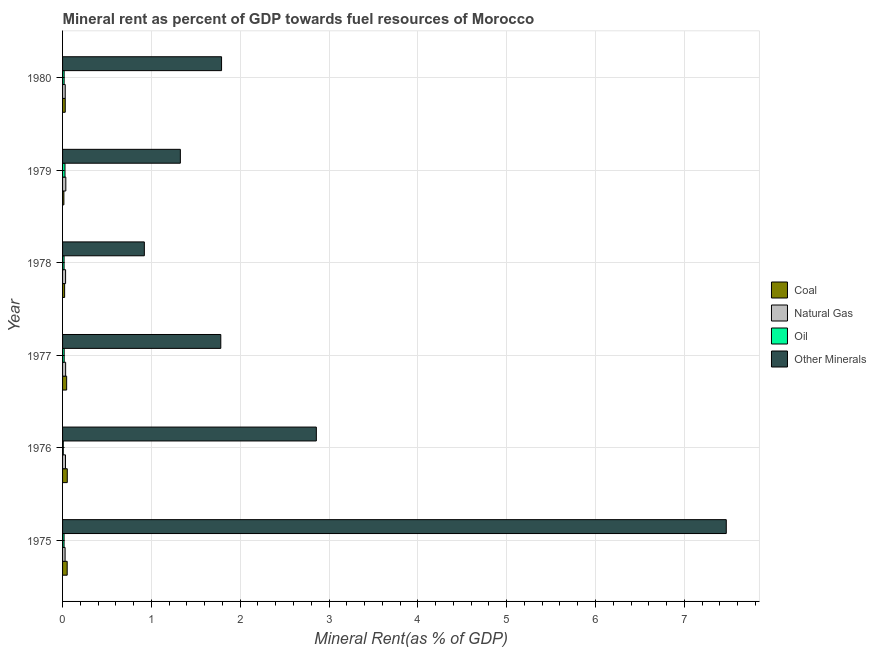Are the number of bars per tick equal to the number of legend labels?
Your response must be concise. Yes. Are the number of bars on each tick of the Y-axis equal?
Offer a terse response. Yes. How many bars are there on the 5th tick from the top?
Give a very brief answer. 4. What is the natural gas rent in 1978?
Give a very brief answer. 0.03. Across all years, what is the maximum  rent of other minerals?
Offer a terse response. 7.47. Across all years, what is the minimum oil rent?
Offer a terse response. 0.01. In which year was the natural gas rent maximum?
Provide a short and direct response. 1979. In which year was the coal rent minimum?
Keep it short and to the point. 1979. What is the total oil rent in the graph?
Make the answer very short. 0.11. What is the difference between the natural gas rent in 1980 and the  rent of other minerals in 1979?
Offer a very short reply. -1.3. What is the average coal rent per year?
Provide a short and direct response. 0.04. In the year 1979, what is the difference between the  rent of other minerals and coal rent?
Offer a very short reply. 1.31. In how many years, is the oil rent greater than 3.8 %?
Your response must be concise. 0. What is the ratio of the oil rent in 1975 to that in 1976?
Your response must be concise. 2.12. What is the difference between the highest and the second highest natural gas rent?
Provide a succinct answer. 0. What is the difference between the highest and the lowest  rent of other minerals?
Offer a very short reply. 6.55. In how many years, is the natural gas rent greater than the average natural gas rent taken over all years?
Offer a terse response. 4. Is it the case that in every year, the sum of the coal rent and oil rent is greater than the sum of  rent of other minerals and natural gas rent?
Provide a succinct answer. No. What does the 4th bar from the top in 1975 represents?
Keep it short and to the point. Coal. What does the 2nd bar from the bottom in 1979 represents?
Make the answer very short. Natural Gas. Is it the case that in every year, the sum of the coal rent and natural gas rent is greater than the oil rent?
Your answer should be compact. Yes. Are all the bars in the graph horizontal?
Your response must be concise. Yes. How many years are there in the graph?
Your answer should be very brief. 6. What is the difference between two consecutive major ticks on the X-axis?
Offer a very short reply. 1. Are the values on the major ticks of X-axis written in scientific E-notation?
Your answer should be compact. No. Does the graph contain any zero values?
Your answer should be very brief. No. What is the title of the graph?
Your answer should be very brief. Mineral rent as percent of GDP towards fuel resources of Morocco. What is the label or title of the X-axis?
Offer a very short reply. Mineral Rent(as % of GDP). What is the label or title of the Y-axis?
Provide a short and direct response. Year. What is the Mineral Rent(as % of GDP) of Coal in 1975?
Your response must be concise. 0.05. What is the Mineral Rent(as % of GDP) of Natural Gas in 1975?
Offer a terse response. 0.03. What is the Mineral Rent(as % of GDP) of Oil in 1975?
Your answer should be compact. 0.02. What is the Mineral Rent(as % of GDP) in Other Minerals in 1975?
Provide a succinct answer. 7.47. What is the Mineral Rent(as % of GDP) of Coal in 1976?
Offer a very short reply. 0.05. What is the Mineral Rent(as % of GDP) of Natural Gas in 1976?
Keep it short and to the point. 0.03. What is the Mineral Rent(as % of GDP) in Oil in 1976?
Offer a very short reply. 0.01. What is the Mineral Rent(as % of GDP) in Other Minerals in 1976?
Your answer should be very brief. 2.86. What is the Mineral Rent(as % of GDP) of Coal in 1977?
Make the answer very short. 0.05. What is the Mineral Rent(as % of GDP) in Natural Gas in 1977?
Your response must be concise. 0.03. What is the Mineral Rent(as % of GDP) of Oil in 1977?
Provide a short and direct response. 0.02. What is the Mineral Rent(as % of GDP) of Other Minerals in 1977?
Provide a succinct answer. 1.78. What is the Mineral Rent(as % of GDP) in Coal in 1978?
Give a very brief answer. 0.02. What is the Mineral Rent(as % of GDP) in Natural Gas in 1978?
Make the answer very short. 0.03. What is the Mineral Rent(as % of GDP) of Oil in 1978?
Your answer should be compact. 0.02. What is the Mineral Rent(as % of GDP) of Other Minerals in 1978?
Make the answer very short. 0.92. What is the Mineral Rent(as % of GDP) of Coal in 1979?
Your response must be concise. 0.01. What is the Mineral Rent(as % of GDP) of Natural Gas in 1979?
Your answer should be compact. 0.04. What is the Mineral Rent(as % of GDP) in Oil in 1979?
Offer a very short reply. 0.03. What is the Mineral Rent(as % of GDP) of Other Minerals in 1979?
Offer a terse response. 1.33. What is the Mineral Rent(as % of GDP) in Coal in 1980?
Your response must be concise. 0.03. What is the Mineral Rent(as % of GDP) of Natural Gas in 1980?
Give a very brief answer. 0.03. What is the Mineral Rent(as % of GDP) in Oil in 1980?
Your answer should be compact. 0.02. What is the Mineral Rent(as % of GDP) in Other Minerals in 1980?
Provide a short and direct response. 1.79. Across all years, what is the maximum Mineral Rent(as % of GDP) of Coal?
Offer a terse response. 0.05. Across all years, what is the maximum Mineral Rent(as % of GDP) of Natural Gas?
Your answer should be compact. 0.04. Across all years, what is the maximum Mineral Rent(as % of GDP) of Oil?
Keep it short and to the point. 0.03. Across all years, what is the maximum Mineral Rent(as % of GDP) in Other Minerals?
Provide a short and direct response. 7.47. Across all years, what is the minimum Mineral Rent(as % of GDP) in Coal?
Give a very brief answer. 0.01. Across all years, what is the minimum Mineral Rent(as % of GDP) in Natural Gas?
Offer a very short reply. 0.03. Across all years, what is the minimum Mineral Rent(as % of GDP) in Oil?
Offer a very short reply. 0.01. Across all years, what is the minimum Mineral Rent(as % of GDP) in Other Minerals?
Offer a terse response. 0.92. What is the total Mineral Rent(as % of GDP) in Coal in the graph?
Your answer should be compact. 0.22. What is the total Mineral Rent(as % of GDP) in Natural Gas in the graph?
Make the answer very short. 0.2. What is the total Mineral Rent(as % of GDP) of Oil in the graph?
Offer a terse response. 0.11. What is the total Mineral Rent(as % of GDP) of Other Minerals in the graph?
Make the answer very short. 16.15. What is the difference between the Mineral Rent(as % of GDP) of Coal in 1975 and that in 1976?
Make the answer very short. -0. What is the difference between the Mineral Rent(as % of GDP) of Natural Gas in 1975 and that in 1976?
Ensure brevity in your answer.  -0. What is the difference between the Mineral Rent(as % of GDP) of Oil in 1975 and that in 1976?
Your answer should be very brief. 0.01. What is the difference between the Mineral Rent(as % of GDP) of Other Minerals in 1975 and that in 1976?
Your answer should be very brief. 4.62. What is the difference between the Mineral Rent(as % of GDP) of Coal in 1975 and that in 1977?
Your answer should be very brief. 0.01. What is the difference between the Mineral Rent(as % of GDP) of Natural Gas in 1975 and that in 1977?
Give a very brief answer. -0.01. What is the difference between the Mineral Rent(as % of GDP) in Oil in 1975 and that in 1977?
Ensure brevity in your answer.  -0. What is the difference between the Mineral Rent(as % of GDP) in Other Minerals in 1975 and that in 1977?
Your answer should be compact. 5.69. What is the difference between the Mineral Rent(as % of GDP) of Coal in 1975 and that in 1978?
Ensure brevity in your answer.  0.03. What is the difference between the Mineral Rent(as % of GDP) in Natural Gas in 1975 and that in 1978?
Offer a terse response. -0.01. What is the difference between the Mineral Rent(as % of GDP) in Oil in 1975 and that in 1978?
Your response must be concise. -0. What is the difference between the Mineral Rent(as % of GDP) of Other Minerals in 1975 and that in 1978?
Provide a succinct answer. 6.55. What is the difference between the Mineral Rent(as % of GDP) in Coal in 1975 and that in 1979?
Keep it short and to the point. 0.04. What is the difference between the Mineral Rent(as % of GDP) in Natural Gas in 1975 and that in 1979?
Provide a short and direct response. -0.01. What is the difference between the Mineral Rent(as % of GDP) of Oil in 1975 and that in 1979?
Make the answer very short. -0.01. What is the difference between the Mineral Rent(as % of GDP) of Other Minerals in 1975 and that in 1979?
Your response must be concise. 6.15. What is the difference between the Mineral Rent(as % of GDP) of Coal in 1975 and that in 1980?
Make the answer very short. 0.02. What is the difference between the Mineral Rent(as % of GDP) of Natural Gas in 1975 and that in 1980?
Your answer should be compact. -0. What is the difference between the Mineral Rent(as % of GDP) in Oil in 1975 and that in 1980?
Make the answer very short. -0. What is the difference between the Mineral Rent(as % of GDP) of Other Minerals in 1975 and that in 1980?
Offer a terse response. 5.68. What is the difference between the Mineral Rent(as % of GDP) of Coal in 1976 and that in 1977?
Make the answer very short. 0.01. What is the difference between the Mineral Rent(as % of GDP) in Natural Gas in 1976 and that in 1977?
Ensure brevity in your answer.  -0. What is the difference between the Mineral Rent(as % of GDP) of Oil in 1976 and that in 1977?
Offer a terse response. -0.01. What is the difference between the Mineral Rent(as % of GDP) of Other Minerals in 1976 and that in 1977?
Ensure brevity in your answer.  1.08. What is the difference between the Mineral Rent(as % of GDP) of Coal in 1976 and that in 1978?
Keep it short and to the point. 0.03. What is the difference between the Mineral Rent(as % of GDP) of Natural Gas in 1976 and that in 1978?
Your answer should be very brief. -0. What is the difference between the Mineral Rent(as % of GDP) of Oil in 1976 and that in 1978?
Your response must be concise. -0.01. What is the difference between the Mineral Rent(as % of GDP) of Other Minerals in 1976 and that in 1978?
Give a very brief answer. 1.94. What is the difference between the Mineral Rent(as % of GDP) in Coal in 1976 and that in 1979?
Your answer should be very brief. 0.04. What is the difference between the Mineral Rent(as % of GDP) of Natural Gas in 1976 and that in 1979?
Your answer should be compact. -0. What is the difference between the Mineral Rent(as % of GDP) of Oil in 1976 and that in 1979?
Offer a very short reply. -0.02. What is the difference between the Mineral Rent(as % of GDP) of Other Minerals in 1976 and that in 1979?
Offer a terse response. 1.53. What is the difference between the Mineral Rent(as % of GDP) of Coal in 1976 and that in 1980?
Provide a succinct answer. 0.02. What is the difference between the Mineral Rent(as % of GDP) in Natural Gas in 1976 and that in 1980?
Keep it short and to the point. 0. What is the difference between the Mineral Rent(as % of GDP) of Oil in 1976 and that in 1980?
Keep it short and to the point. -0.01. What is the difference between the Mineral Rent(as % of GDP) of Other Minerals in 1976 and that in 1980?
Your answer should be compact. 1.07. What is the difference between the Mineral Rent(as % of GDP) of Coal in 1977 and that in 1978?
Ensure brevity in your answer.  0.02. What is the difference between the Mineral Rent(as % of GDP) in Oil in 1977 and that in 1978?
Give a very brief answer. 0. What is the difference between the Mineral Rent(as % of GDP) in Other Minerals in 1977 and that in 1978?
Ensure brevity in your answer.  0.86. What is the difference between the Mineral Rent(as % of GDP) of Coal in 1977 and that in 1979?
Your answer should be very brief. 0.03. What is the difference between the Mineral Rent(as % of GDP) of Natural Gas in 1977 and that in 1979?
Your answer should be compact. -0. What is the difference between the Mineral Rent(as % of GDP) in Oil in 1977 and that in 1979?
Ensure brevity in your answer.  -0.01. What is the difference between the Mineral Rent(as % of GDP) in Other Minerals in 1977 and that in 1979?
Keep it short and to the point. 0.46. What is the difference between the Mineral Rent(as % of GDP) in Coal in 1977 and that in 1980?
Keep it short and to the point. 0.02. What is the difference between the Mineral Rent(as % of GDP) of Natural Gas in 1977 and that in 1980?
Offer a terse response. 0. What is the difference between the Mineral Rent(as % of GDP) in Oil in 1977 and that in 1980?
Your answer should be compact. 0. What is the difference between the Mineral Rent(as % of GDP) of Other Minerals in 1977 and that in 1980?
Provide a short and direct response. -0.01. What is the difference between the Mineral Rent(as % of GDP) in Coal in 1978 and that in 1979?
Make the answer very short. 0.01. What is the difference between the Mineral Rent(as % of GDP) of Natural Gas in 1978 and that in 1979?
Ensure brevity in your answer.  -0. What is the difference between the Mineral Rent(as % of GDP) in Oil in 1978 and that in 1979?
Provide a short and direct response. -0.01. What is the difference between the Mineral Rent(as % of GDP) of Other Minerals in 1978 and that in 1979?
Offer a very short reply. -0.41. What is the difference between the Mineral Rent(as % of GDP) in Coal in 1978 and that in 1980?
Provide a succinct answer. -0.01. What is the difference between the Mineral Rent(as % of GDP) in Natural Gas in 1978 and that in 1980?
Your response must be concise. 0. What is the difference between the Mineral Rent(as % of GDP) in Oil in 1978 and that in 1980?
Provide a short and direct response. -0. What is the difference between the Mineral Rent(as % of GDP) of Other Minerals in 1978 and that in 1980?
Ensure brevity in your answer.  -0.87. What is the difference between the Mineral Rent(as % of GDP) in Coal in 1979 and that in 1980?
Give a very brief answer. -0.02. What is the difference between the Mineral Rent(as % of GDP) of Natural Gas in 1979 and that in 1980?
Offer a very short reply. 0.01. What is the difference between the Mineral Rent(as % of GDP) in Oil in 1979 and that in 1980?
Provide a succinct answer. 0.01. What is the difference between the Mineral Rent(as % of GDP) of Other Minerals in 1979 and that in 1980?
Offer a very short reply. -0.46. What is the difference between the Mineral Rent(as % of GDP) of Coal in 1975 and the Mineral Rent(as % of GDP) of Natural Gas in 1976?
Your response must be concise. 0.02. What is the difference between the Mineral Rent(as % of GDP) of Coal in 1975 and the Mineral Rent(as % of GDP) of Oil in 1976?
Provide a short and direct response. 0.04. What is the difference between the Mineral Rent(as % of GDP) of Coal in 1975 and the Mineral Rent(as % of GDP) of Other Minerals in 1976?
Ensure brevity in your answer.  -2.81. What is the difference between the Mineral Rent(as % of GDP) in Natural Gas in 1975 and the Mineral Rent(as % of GDP) in Oil in 1976?
Your answer should be compact. 0.02. What is the difference between the Mineral Rent(as % of GDP) in Natural Gas in 1975 and the Mineral Rent(as % of GDP) in Other Minerals in 1976?
Make the answer very short. -2.83. What is the difference between the Mineral Rent(as % of GDP) of Oil in 1975 and the Mineral Rent(as % of GDP) of Other Minerals in 1976?
Give a very brief answer. -2.84. What is the difference between the Mineral Rent(as % of GDP) in Coal in 1975 and the Mineral Rent(as % of GDP) in Natural Gas in 1977?
Your response must be concise. 0.02. What is the difference between the Mineral Rent(as % of GDP) of Coal in 1975 and the Mineral Rent(as % of GDP) of Oil in 1977?
Offer a terse response. 0.03. What is the difference between the Mineral Rent(as % of GDP) in Coal in 1975 and the Mineral Rent(as % of GDP) in Other Minerals in 1977?
Provide a succinct answer. -1.73. What is the difference between the Mineral Rent(as % of GDP) in Natural Gas in 1975 and the Mineral Rent(as % of GDP) in Oil in 1977?
Ensure brevity in your answer.  0.01. What is the difference between the Mineral Rent(as % of GDP) in Natural Gas in 1975 and the Mineral Rent(as % of GDP) in Other Minerals in 1977?
Your answer should be compact. -1.75. What is the difference between the Mineral Rent(as % of GDP) in Oil in 1975 and the Mineral Rent(as % of GDP) in Other Minerals in 1977?
Ensure brevity in your answer.  -1.76. What is the difference between the Mineral Rent(as % of GDP) in Coal in 1975 and the Mineral Rent(as % of GDP) in Natural Gas in 1978?
Offer a very short reply. 0.02. What is the difference between the Mineral Rent(as % of GDP) of Coal in 1975 and the Mineral Rent(as % of GDP) of Oil in 1978?
Give a very brief answer. 0.04. What is the difference between the Mineral Rent(as % of GDP) in Coal in 1975 and the Mineral Rent(as % of GDP) in Other Minerals in 1978?
Offer a very short reply. -0.87. What is the difference between the Mineral Rent(as % of GDP) in Natural Gas in 1975 and the Mineral Rent(as % of GDP) in Oil in 1978?
Provide a succinct answer. 0.01. What is the difference between the Mineral Rent(as % of GDP) in Natural Gas in 1975 and the Mineral Rent(as % of GDP) in Other Minerals in 1978?
Give a very brief answer. -0.89. What is the difference between the Mineral Rent(as % of GDP) in Oil in 1975 and the Mineral Rent(as % of GDP) in Other Minerals in 1978?
Give a very brief answer. -0.9. What is the difference between the Mineral Rent(as % of GDP) in Coal in 1975 and the Mineral Rent(as % of GDP) in Natural Gas in 1979?
Keep it short and to the point. 0.02. What is the difference between the Mineral Rent(as % of GDP) in Coal in 1975 and the Mineral Rent(as % of GDP) in Oil in 1979?
Your answer should be very brief. 0.02. What is the difference between the Mineral Rent(as % of GDP) in Coal in 1975 and the Mineral Rent(as % of GDP) in Other Minerals in 1979?
Ensure brevity in your answer.  -1.27. What is the difference between the Mineral Rent(as % of GDP) of Natural Gas in 1975 and the Mineral Rent(as % of GDP) of Oil in 1979?
Your answer should be very brief. 0. What is the difference between the Mineral Rent(as % of GDP) of Natural Gas in 1975 and the Mineral Rent(as % of GDP) of Other Minerals in 1979?
Ensure brevity in your answer.  -1.3. What is the difference between the Mineral Rent(as % of GDP) of Oil in 1975 and the Mineral Rent(as % of GDP) of Other Minerals in 1979?
Offer a very short reply. -1.31. What is the difference between the Mineral Rent(as % of GDP) of Coal in 1975 and the Mineral Rent(as % of GDP) of Natural Gas in 1980?
Provide a succinct answer. 0.02. What is the difference between the Mineral Rent(as % of GDP) of Coal in 1975 and the Mineral Rent(as % of GDP) of Oil in 1980?
Offer a terse response. 0.03. What is the difference between the Mineral Rent(as % of GDP) in Coal in 1975 and the Mineral Rent(as % of GDP) in Other Minerals in 1980?
Your answer should be compact. -1.74. What is the difference between the Mineral Rent(as % of GDP) of Natural Gas in 1975 and the Mineral Rent(as % of GDP) of Oil in 1980?
Your answer should be compact. 0.01. What is the difference between the Mineral Rent(as % of GDP) of Natural Gas in 1975 and the Mineral Rent(as % of GDP) of Other Minerals in 1980?
Your response must be concise. -1.76. What is the difference between the Mineral Rent(as % of GDP) of Oil in 1975 and the Mineral Rent(as % of GDP) of Other Minerals in 1980?
Your answer should be very brief. -1.77. What is the difference between the Mineral Rent(as % of GDP) in Coal in 1976 and the Mineral Rent(as % of GDP) in Natural Gas in 1977?
Provide a short and direct response. 0.02. What is the difference between the Mineral Rent(as % of GDP) of Coal in 1976 and the Mineral Rent(as % of GDP) of Oil in 1977?
Keep it short and to the point. 0.03. What is the difference between the Mineral Rent(as % of GDP) in Coal in 1976 and the Mineral Rent(as % of GDP) in Other Minerals in 1977?
Keep it short and to the point. -1.73. What is the difference between the Mineral Rent(as % of GDP) of Natural Gas in 1976 and the Mineral Rent(as % of GDP) of Oil in 1977?
Your answer should be very brief. 0.01. What is the difference between the Mineral Rent(as % of GDP) in Natural Gas in 1976 and the Mineral Rent(as % of GDP) in Other Minerals in 1977?
Make the answer very short. -1.75. What is the difference between the Mineral Rent(as % of GDP) in Oil in 1976 and the Mineral Rent(as % of GDP) in Other Minerals in 1977?
Provide a short and direct response. -1.77. What is the difference between the Mineral Rent(as % of GDP) of Coal in 1976 and the Mineral Rent(as % of GDP) of Natural Gas in 1978?
Your answer should be compact. 0.02. What is the difference between the Mineral Rent(as % of GDP) of Coal in 1976 and the Mineral Rent(as % of GDP) of Oil in 1978?
Your answer should be compact. 0.04. What is the difference between the Mineral Rent(as % of GDP) in Coal in 1976 and the Mineral Rent(as % of GDP) in Other Minerals in 1978?
Your answer should be very brief. -0.87. What is the difference between the Mineral Rent(as % of GDP) in Natural Gas in 1976 and the Mineral Rent(as % of GDP) in Oil in 1978?
Your answer should be very brief. 0.02. What is the difference between the Mineral Rent(as % of GDP) in Natural Gas in 1976 and the Mineral Rent(as % of GDP) in Other Minerals in 1978?
Offer a terse response. -0.89. What is the difference between the Mineral Rent(as % of GDP) in Oil in 1976 and the Mineral Rent(as % of GDP) in Other Minerals in 1978?
Your response must be concise. -0.91. What is the difference between the Mineral Rent(as % of GDP) of Coal in 1976 and the Mineral Rent(as % of GDP) of Natural Gas in 1979?
Offer a terse response. 0.02. What is the difference between the Mineral Rent(as % of GDP) of Coal in 1976 and the Mineral Rent(as % of GDP) of Oil in 1979?
Offer a terse response. 0.03. What is the difference between the Mineral Rent(as % of GDP) in Coal in 1976 and the Mineral Rent(as % of GDP) in Other Minerals in 1979?
Provide a succinct answer. -1.27. What is the difference between the Mineral Rent(as % of GDP) of Natural Gas in 1976 and the Mineral Rent(as % of GDP) of Oil in 1979?
Provide a short and direct response. 0.01. What is the difference between the Mineral Rent(as % of GDP) in Natural Gas in 1976 and the Mineral Rent(as % of GDP) in Other Minerals in 1979?
Ensure brevity in your answer.  -1.29. What is the difference between the Mineral Rent(as % of GDP) of Oil in 1976 and the Mineral Rent(as % of GDP) of Other Minerals in 1979?
Offer a very short reply. -1.32. What is the difference between the Mineral Rent(as % of GDP) of Coal in 1976 and the Mineral Rent(as % of GDP) of Natural Gas in 1980?
Make the answer very short. 0.02. What is the difference between the Mineral Rent(as % of GDP) in Coal in 1976 and the Mineral Rent(as % of GDP) in Oil in 1980?
Keep it short and to the point. 0.04. What is the difference between the Mineral Rent(as % of GDP) of Coal in 1976 and the Mineral Rent(as % of GDP) of Other Minerals in 1980?
Offer a very short reply. -1.74. What is the difference between the Mineral Rent(as % of GDP) in Natural Gas in 1976 and the Mineral Rent(as % of GDP) in Oil in 1980?
Ensure brevity in your answer.  0.01. What is the difference between the Mineral Rent(as % of GDP) of Natural Gas in 1976 and the Mineral Rent(as % of GDP) of Other Minerals in 1980?
Provide a short and direct response. -1.76. What is the difference between the Mineral Rent(as % of GDP) in Oil in 1976 and the Mineral Rent(as % of GDP) in Other Minerals in 1980?
Provide a short and direct response. -1.78. What is the difference between the Mineral Rent(as % of GDP) of Coal in 1977 and the Mineral Rent(as % of GDP) of Natural Gas in 1978?
Offer a very short reply. 0.01. What is the difference between the Mineral Rent(as % of GDP) in Coal in 1977 and the Mineral Rent(as % of GDP) in Oil in 1978?
Offer a terse response. 0.03. What is the difference between the Mineral Rent(as % of GDP) in Coal in 1977 and the Mineral Rent(as % of GDP) in Other Minerals in 1978?
Offer a terse response. -0.87. What is the difference between the Mineral Rent(as % of GDP) in Natural Gas in 1977 and the Mineral Rent(as % of GDP) in Oil in 1978?
Your response must be concise. 0.02. What is the difference between the Mineral Rent(as % of GDP) of Natural Gas in 1977 and the Mineral Rent(as % of GDP) of Other Minerals in 1978?
Make the answer very short. -0.89. What is the difference between the Mineral Rent(as % of GDP) in Oil in 1977 and the Mineral Rent(as % of GDP) in Other Minerals in 1978?
Your answer should be compact. -0.9. What is the difference between the Mineral Rent(as % of GDP) in Coal in 1977 and the Mineral Rent(as % of GDP) in Natural Gas in 1979?
Provide a succinct answer. 0.01. What is the difference between the Mineral Rent(as % of GDP) in Coal in 1977 and the Mineral Rent(as % of GDP) in Oil in 1979?
Your response must be concise. 0.02. What is the difference between the Mineral Rent(as % of GDP) in Coal in 1977 and the Mineral Rent(as % of GDP) in Other Minerals in 1979?
Ensure brevity in your answer.  -1.28. What is the difference between the Mineral Rent(as % of GDP) of Natural Gas in 1977 and the Mineral Rent(as % of GDP) of Oil in 1979?
Your answer should be very brief. 0.01. What is the difference between the Mineral Rent(as % of GDP) in Natural Gas in 1977 and the Mineral Rent(as % of GDP) in Other Minerals in 1979?
Offer a terse response. -1.29. What is the difference between the Mineral Rent(as % of GDP) in Oil in 1977 and the Mineral Rent(as % of GDP) in Other Minerals in 1979?
Offer a very short reply. -1.31. What is the difference between the Mineral Rent(as % of GDP) of Coal in 1977 and the Mineral Rent(as % of GDP) of Natural Gas in 1980?
Offer a terse response. 0.02. What is the difference between the Mineral Rent(as % of GDP) in Coal in 1977 and the Mineral Rent(as % of GDP) in Oil in 1980?
Offer a terse response. 0.03. What is the difference between the Mineral Rent(as % of GDP) of Coal in 1977 and the Mineral Rent(as % of GDP) of Other Minerals in 1980?
Provide a succinct answer. -1.74. What is the difference between the Mineral Rent(as % of GDP) in Natural Gas in 1977 and the Mineral Rent(as % of GDP) in Oil in 1980?
Give a very brief answer. 0.02. What is the difference between the Mineral Rent(as % of GDP) of Natural Gas in 1977 and the Mineral Rent(as % of GDP) of Other Minerals in 1980?
Give a very brief answer. -1.76. What is the difference between the Mineral Rent(as % of GDP) of Oil in 1977 and the Mineral Rent(as % of GDP) of Other Minerals in 1980?
Your answer should be very brief. -1.77. What is the difference between the Mineral Rent(as % of GDP) in Coal in 1978 and the Mineral Rent(as % of GDP) in Natural Gas in 1979?
Provide a succinct answer. -0.01. What is the difference between the Mineral Rent(as % of GDP) in Coal in 1978 and the Mineral Rent(as % of GDP) in Oil in 1979?
Your answer should be compact. -0. What is the difference between the Mineral Rent(as % of GDP) in Coal in 1978 and the Mineral Rent(as % of GDP) in Other Minerals in 1979?
Provide a short and direct response. -1.3. What is the difference between the Mineral Rent(as % of GDP) in Natural Gas in 1978 and the Mineral Rent(as % of GDP) in Oil in 1979?
Provide a succinct answer. 0.01. What is the difference between the Mineral Rent(as % of GDP) in Natural Gas in 1978 and the Mineral Rent(as % of GDP) in Other Minerals in 1979?
Provide a succinct answer. -1.29. What is the difference between the Mineral Rent(as % of GDP) in Oil in 1978 and the Mineral Rent(as % of GDP) in Other Minerals in 1979?
Ensure brevity in your answer.  -1.31. What is the difference between the Mineral Rent(as % of GDP) of Coal in 1978 and the Mineral Rent(as % of GDP) of Natural Gas in 1980?
Offer a very short reply. -0.01. What is the difference between the Mineral Rent(as % of GDP) in Coal in 1978 and the Mineral Rent(as % of GDP) in Oil in 1980?
Give a very brief answer. 0.01. What is the difference between the Mineral Rent(as % of GDP) of Coal in 1978 and the Mineral Rent(as % of GDP) of Other Minerals in 1980?
Make the answer very short. -1.77. What is the difference between the Mineral Rent(as % of GDP) in Natural Gas in 1978 and the Mineral Rent(as % of GDP) in Oil in 1980?
Provide a short and direct response. 0.02. What is the difference between the Mineral Rent(as % of GDP) of Natural Gas in 1978 and the Mineral Rent(as % of GDP) of Other Minerals in 1980?
Keep it short and to the point. -1.76. What is the difference between the Mineral Rent(as % of GDP) in Oil in 1978 and the Mineral Rent(as % of GDP) in Other Minerals in 1980?
Your answer should be very brief. -1.77. What is the difference between the Mineral Rent(as % of GDP) in Coal in 1979 and the Mineral Rent(as % of GDP) in Natural Gas in 1980?
Make the answer very short. -0.02. What is the difference between the Mineral Rent(as % of GDP) in Coal in 1979 and the Mineral Rent(as % of GDP) in Oil in 1980?
Provide a succinct answer. -0. What is the difference between the Mineral Rent(as % of GDP) in Coal in 1979 and the Mineral Rent(as % of GDP) in Other Minerals in 1980?
Provide a succinct answer. -1.78. What is the difference between the Mineral Rent(as % of GDP) of Natural Gas in 1979 and the Mineral Rent(as % of GDP) of Oil in 1980?
Keep it short and to the point. 0.02. What is the difference between the Mineral Rent(as % of GDP) of Natural Gas in 1979 and the Mineral Rent(as % of GDP) of Other Minerals in 1980?
Give a very brief answer. -1.75. What is the difference between the Mineral Rent(as % of GDP) of Oil in 1979 and the Mineral Rent(as % of GDP) of Other Minerals in 1980?
Your response must be concise. -1.76. What is the average Mineral Rent(as % of GDP) of Coal per year?
Offer a terse response. 0.04. What is the average Mineral Rent(as % of GDP) of Natural Gas per year?
Keep it short and to the point. 0.03. What is the average Mineral Rent(as % of GDP) of Oil per year?
Your response must be concise. 0.02. What is the average Mineral Rent(as % of GDP) of Other Minerals per year?
Provide a short and direct response. 2.69. In the year 1975, what is the difference between the Mineral Rent(as % of GDP) of Coal and Mineral Rent(as % of GDP) of Natural Gas?
Provide a succinct answer. 0.02. In the year 1975, what is the difference between the Mineral Rent(as % of GDP) in Coal and Mineral Rent(as % of GDP) in Oil?
Make the answer very short. 0.04. In the year 1975, what is the difference between the Mineral Rent(as % of GDP) in Coal and Mineral Rent(as % of GDP) in Other Minerals?
Make the answer very short. -7.42. In the year 1975, what is the difference between the Mineral Rent(as % of GDP) of Natural Gas and Mineral Rent(as % of GDP) of Oil?
Your answer should be very brief. 0.01. In the year 1975, what is the difference between the Mineral Rent(as % of GDP) in Natural Gas and Mineral Rent(as % of GDP) in Other Minerals?
Give a very brief answer. -7.44. In the year 1975, what is the difference between the Mineral Rent(as % of GDP) of Oil and Mineral Rent(as % of GDP) of Other Minerals?
Ensure brevity in your answer.  -7.46. In the year 1976, what is the difference between the Mineral Rent(as % of GDP) of Coal and Mineral Rent(as % of GDP) of Natural Gas?
Keep it short and to the point. 0.02. In the year 1976, what is the difference between the Mineral Rent(as % of GDP) in Coal and Mineral Rent(as % of GDP) in Oil?
Offer a terse response. 0.05. In the year 1976, what is the difference between the Mineral Rent(as % of GDP) of Coal and Mineral Rent(as % of GDP) of Other Minerals?
Provide a short and direct response. -2.8. In the year 1976, what is the difference between the Mineral Rent(as % of GDP) of Natural Gas and Mineral Rent(as % of GDP) of Oil?
Give a very brief answer. 0.02. In the year 1976, what is the difference between the Mineral Rent(as % of GDP) of Natural Gas and Mineral Rent(as % of GDP) of Other Minerals?
Offer a very short reply. -2.82. In the year 1976, what is the difference between the Mineral Rent(as % of GDP) of Oil and Mineral Rent(as % of GDP) of Other Minerals?
Give a very brief answer. -2.85. In the year 1977, what is the difference between the Mineral Rent(as % of GDP) of Coal and Mineral Rent(as % of GDP) of Natural Gas?
Offer a very short reply. 0.01. In the year 1977, what is the difference between the Mineral Rent(as % of GDP) in Coal and Mineral Rent(as % of GDP) in Oil?
Keep it short and to the point. 0.03. In the year 1977, what is the difference between the Mineral Rent(as % of GDP) in Coal and Mineral Rent(as % of GDP) in Other Minerals?
Your answer should be compact. -1.74. In the year 1977, what is the difference between the Mineral Rent(as % of GDP) in Natural Gas and Mineral Rent(as % of GDP) in Oil?
Offer a very short reply. 0.02. In the year 1977, what is the difference between the Mineral Rent(as % of GDP) of Natural Gas and Mineral Rent(as % of GDP) of Other Minerals?
Give a very brief answer. -1.75. In the year 1977, what is the difference between the Mineral Rent(as % of GDP) in Oil and Mineral Rent(as % of GDP) in Other Minerals?
Provide a short and direct response. -1.76. In the year 1978, what is the difference between the Mineral Rent(as % of GDP) in Coal and Mineral Rent(as % of GDP) in Natural Gas?
Your answer should be very brief. -0.01. In the year 1978, what is the difference between the Mineral Rent(as % of GDP) in Coal and Mineral Rent(as % of GDP) in Oil?
Ensure brevity in your answer.  0.01. In the year 1978, what is the difference between the Mineral Rent(as % of GDP) in Coal and Mineral Rent(as % of GDP) in Other Minerals?
Ensure brevity in your answer.  -0.9. In the year 1978, what is the difference between the Mineral Rent(as % of GDP) of Natural Gas and Mineral Rent(as % of GDP) of Oil?
Provide a succinct answer. 0.02. In the year 1978, what is the difference between the Mineral Rent(as % of GDP) of Natural Gas and Mineral Rent(as % of GDP) of Other Minerals?
Ensure brevity in your answer.  -0.89. In the year 1978, what is the difference between the Mineral Rent(as % of GDP) of Oil and Mineral Rent(as % of GDP) of Other Minerals?
Make the answer very short. -0.9. In the year 1979, what is the difference between the Mineral Rent(as % of GDP) of Coal and Mineral Rent(as % of GDP) of Natural Gas?
Make the answer very short. -0.02. In the year 1979, what is the difference between the Mineral Rent(as % of GDP) in Coal and Mineral Rent(as % of GDP) in Oil?
Provide a short and direct response. -0.01. In the year 1979, what is the difference between the Mineral Rent(as % of GDP) of Coal and Mineral Rent(as % of GDP) of Other Minerals?
Keep it short and to the point. -1.31. In the year 1979, what is the difference between the Mineral Rent(as % of GDP) of Natural Gas and Mineral Rent(as % of GDP) of Oil?
Provide a succinct answer. 0.01. In the year 1979, what is the difference between the Mineral Rent(as % of GDP) of Natural Gas and Mineral Rent(as % of GDP) of Other Minerals?
Ensure brevity in your answer.  -1.29. In the year 1979, what is the difference between the Mineral Rent(as % of GDP) in Oil and Mineral Rent(as % of GDP) in Other Minerals?
Your response must be concise. -1.3. In the year 1980, what is the difference between the Mineral Rent(as % of GDP) of Coal and Mineral Rent(as % of GDP) of Oil?
Give a very brief answer. 0.01. In the year 1980, what is the difference between the Mineral Rent(as % of GDP) of Coal and Mineral Rent(as % of GDP) of Other Minerals?
Provide a short and direct response. -1.76. In the year 1980, what is the difference between the Mineral Rent(as % of GDP) in Natural Gas and Mineral Rent(as % of GDP) in Oil?
Provide a short and direct response. 0.01. In the year 1980, what is the difference between the Mineral Rent(as % of GDP) in Natural Gas and Mineral Rent(as % of GDP) in Other Minerals?
Provide a short and direct response. -1.76. In the year 1980, what is the difference between the Mineral Rent(as % of GDP) in Oil and Mineral Rent(as % of GDP) in Other Minerals?
Your response must be concise. -1.77. What is the ratio of the Mineral Rent(as % of GDP) in Coal in 1975 to that in 1976?
Give a very brief answer. 0.98. What is the ratio of the Mineral Rent(as % of GDP) of Natural Gas in 1975 to that in 1976?
Make the answer very short. 0.87. What is the ratio of the Mineral Rent(as % of GDP) of Oil in 1975 to that in 1976?
Your answer should be compact. 2.12. What is the ratio of the Mineral Rent(as % of GDP) of Other Minerals in 1975 to that in 1976?
Provide a succinct answer. 2.62. What is the ratio of the Mineral Rent(as % of GDP) of Coal in 1975 to that in 1977?
Offer a very short reply. 1.13. What is the ratio of the Mineral Rent(as % of GDP) of Natural Gas in 1975 to that in 1977?
Your answer should be compact. 0.82. What is the ratio of the Mineral Rent(as % of GDP) in Oil in 1975 to that in 1977?
Your answer should be very brief. 0.93. What is the ratio of the Mineral Rent(as % of GDP) in Other Minerals in 1975 to that in 1977?
Offer a terse response. 4.19. What is the ratio of the Mineral Rent(as % of GDP) in Coal in 1975 to that in 1978?
Provide a succinct answer. 2.25. What is the ratio of the Mineral Rent(as % of GDP) in Natural Gas in 1975 to that in 1978?
Offer a terse response. 0.83. What is the ratio of the Mineral Rent(as % of GDP) in Oil in 1975 to that in 1978?
Offer a terse response. 0.99. What is the ratio of the Mineral Rent(as % of GDP) in Other Minerals in 1975 to that in 1978?
Your answer should be very brief. 8.12. What is the ratio of the Mineral Rent(as % of GDP) in Coal in 1975 to that in 1979?
Offer a very short reply. 3.49. What is the ratio of the Mineral Rent(as % of GDP) in Natural Gas in 1975 to that in 1979?
Keep it short and to the point. 0.77. What is the ratio of the Mineral Rent(as % of GDP) in Oil in 1975 to that in 1979?
Provide a succinct answer. 0.62. What is the ratio of the Mineral Rent(as % of GDP) of Other Minerals in 1975 to that in 1979?
Your response must be concise. 5.63. What is the ratio of the Mineral Rent(as % of GDP) of Coal in 1975 to that in 1980?
Your response must be concise. 1.72. What is the ratio of the Mineral Rent(as % of GDP) of Natural Gas in 1975 to that in 1980?
Your answer should be compact. 0.95. What is the ratio of the Mineral Rent(as % of GDP) of Oil in 1975 to that in 1980?
Offer a terse response. 0.95. What is the ratio of the Mineral Rent(as % of GDP) in Other Minerals in 1975 to that in 1980?
Your answer should be very brief. 4.17. What is the ratio of the Mineral Rent(as % of GDP) of Coal in 1976 to that in 1977?
Provide a succinct answer. 1.15. What is the ratio of the Mineral Rent(as % of GDP) in Natural Gas in 1976 to that in 1977?
Provide a short and direct response. 0.95. What is the ratio of the Mineral Rent(as % of GDP) in Oil in 1976 to that in 1977?
Provide a succinct answer. 0.44. What is the ratio of the Mineral Rent(as % of GDP) in Other Minerals in 1976 to that in 1977?
Keep it short and to the point. 1.6. What is the ratio of the Mineral Rent(as % of GDP) in Coal in 1976 to that in 1978?
Give a very brief answer. 2.29. What is the ratio of the Mineral Rent(as % of GDP) in Natural Gas in 1976 to that in 1978?
Ensure brevity in your answer.  0.96. What is the ratio of the Mineral Rent(as % of GDP) in Oil in 1976 to that in 1978?
Make the answer very short. 0.47. What is the ratio of the Mineral Rent(as % of GDP) of Other Minerals in 1976 to that in 1978?
Your response must be concise. 3.1. What is the ratio of the Mineral Rent(as % of GDP) of Coal in 1976 to that in 1979?
Offer a terse response. 3.56. What is the ratio of the Mineral Rent(as % of GDP) in Natural Gas in 1976 to that in 1979?
Your answer should be very brief. 0.89. What is the ratio of the Mineral Rent(as % of GDP) of Oil in 1976 to that in 1979?
Provide a succinct answer. 0.29. What is the ratio of the Mineral Rent(as % of GDP) in Other Minerals in 1976 to that in 1979?
Provide a succinct answer. 2.15. What is the ratio of the Mineral Rent(as % of GDP) of Coal in 1976 to that in 1980?
Your answer should be compact. 1.76. What is the ratio of the Mineral Rent(as % of GDP) of Natural Gas in 1976 to that in 1980?
Offer a very short reply. 1.09. What is the ratio of the Mineral Rent(as % of GDP) in Oil in 1976 to that in 1980?
Your answer should be very brief. 0.45. What is the ratio of the Mineral Rent(as % of GDP) in Other Minerals in 1976 to that in 1980?
Your answer should be compact. 1.6. What is the ratio of the Mineral Rent(as % of GDP) of Coal in 1977 to that in 1978?
Offer a terse response. 1.99. What is the ratio of the Mineral Rent(as % of GDP) of Natural Gas in 1977 to that in 1978?
Make the answer very short. 1.01. What is the ratio of the Mineral Rent(as % of GDP) of Oil in 1977 to that in 1978?
Offer a very short reply. 1.07. What is the ratio of the Mineral Rent(as % of GDP) of Other Minerals in 1977 to that in 1978?
Provide a succinct answer. 1.93. What is the ratio of the Mineral Rent(as % of GDP) in Coal in 1977 to that in 1979?
Keep it short and to the point. 3.09. What is the ratio of the Mineral Rent(as % of GDP) in Natural Gas in 1977 to that in 1979?
Make the answer very short. 0.94. What is the ratio of the Mineral Rent(as % of GDP) in Oil in 1977 to that in 1979?
Your answer should be compact. 0.66. What is the ratio of the Mineral Rent(as % of GDP) of Other Minerals in 1977 to that in 1979?
Offer a terse response. 1.34. What is the ratio of the Mineral Rent(as % of GDP) in Coal in 1977 to that in 1980?
Give a very brief answer. 1.52. What is the ratio of the Mineral Rent(as % of GDP) in Natural Gas in 1977 to that in 1980?
Your answer should be compact. 1.15. What is the ratio of the Mineral Rent(as % of GDP) in Oil in 1977 to that in 1980?
Offer a very short reply. 1.03. What is the ratio of the Mineral Rent(as % of GDP) in Coal in 1978 to that in 1979?
Keep it short and to the point. 1.55. What is the ratio of the Mineral Rent(as % of GDP) in Natural Gas in 1978 to that in 1979?
Offer a very short reply. 0.93. What is the ratio of the Mineral Rent(as % of GDP) in Oil in 1978 to that in 1979?
Ensure brevity in your answer.  0.62. What is the ratio of the Mineral Rent(as % of GDP) in Other Minerals in 1978 to that in 1979?
Make the answer very short. 0.69. What is the ratio of the Mineral Rent(as % of GDP) of Coal in 1978 to that in 1980?
Offer a very short reply. 0.77. What is the ratio of the Mineral Rent(as % of GDP) in Natural Gas in 1978 to that in 1980?
Provide a short and direct response. 1.14. What is the ratio of the Mineral Rent(as % of GDP) of Oil in 1978 to that in 1980?
Provide a succinct answer. 0.96. What is the ratio of the Mineral Rent(as % of GDP) in Other Minerals in 1978 to that in 1980?
Make the answer very short. 0.51. What is the ratio of the Mineral Rent(as % of GDP) of Coal in 1979 to that in 1980?
Offer a very short reply. 0.49. What is the ratio of the Mineral Rent(as % of GDP) in Natural Gas in 1979 to that in 1980?
Your response must be concise. 1.22. What is the ratio of the Mineral Rent(as % of GDP) of Oil in 1979 to that in 1980?
Your response must be concise. 1.55. What is the ratio of the Mineral Rent(as % of GDP) in Other Minerals in 1979 to that in 1980?
Keep it short and to the point. 0.74. What is the difference between the highest and the second highest Mineral Rent(as % of GDP) in Coal?
Offer a terse response. 0. What is the difference between the highest and the second highest Mineral Rent(as % of GDP) of Natural Gas?
Your answer should be very brief. 0. What is the difference between the highest and the second highest Mineral Rent(as % of GDP) in Oil?
Your response must be concise. 0.01. What is the difference between the highest and the second highest Mineral Rent(as % of GDP) of Other Minerals?
Ensure brevity in your answer.  4.62. What is the difference between the highest and the lowest Mineral Rent(as % of GDP) in Coal?
Provide a succinct answer. 0.04. What is the difference between the highest and the lowest Mineral Rent(as % of GDP) in Natural Gas?
Make the answer very short. 0.01. What is the difference between the highest and the lowest Mineral Rent(as % of GDP) in Oil?
Ensure brevity in your answer.  0.02. What is the difference between the highest and the lowest Mineral Rent(as % of GDP) in Other Minerals?
Provide a succinct answer. 6.55. 